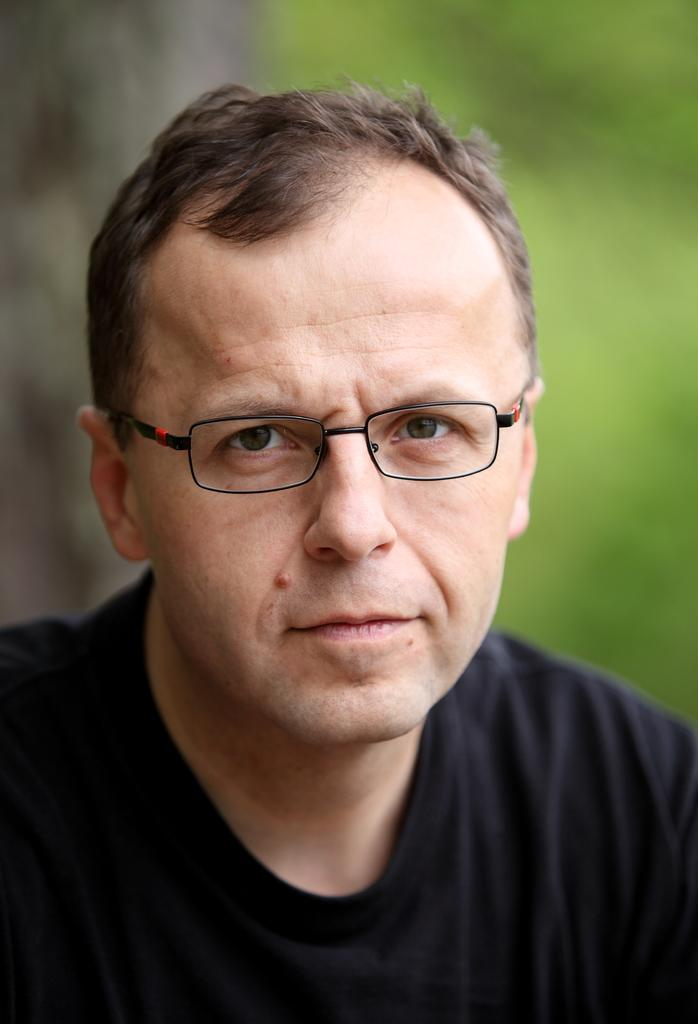Who is the main subject in the image? There is a man in the image. Where is the man located in the image? The man is in the center of the image. What is the man wearing in the image? The man is wearing a black shirt. What type of plantation can be seen in the background of the image? There is no plantation present in the image; it only features a man in the center wearing a black shirt. 